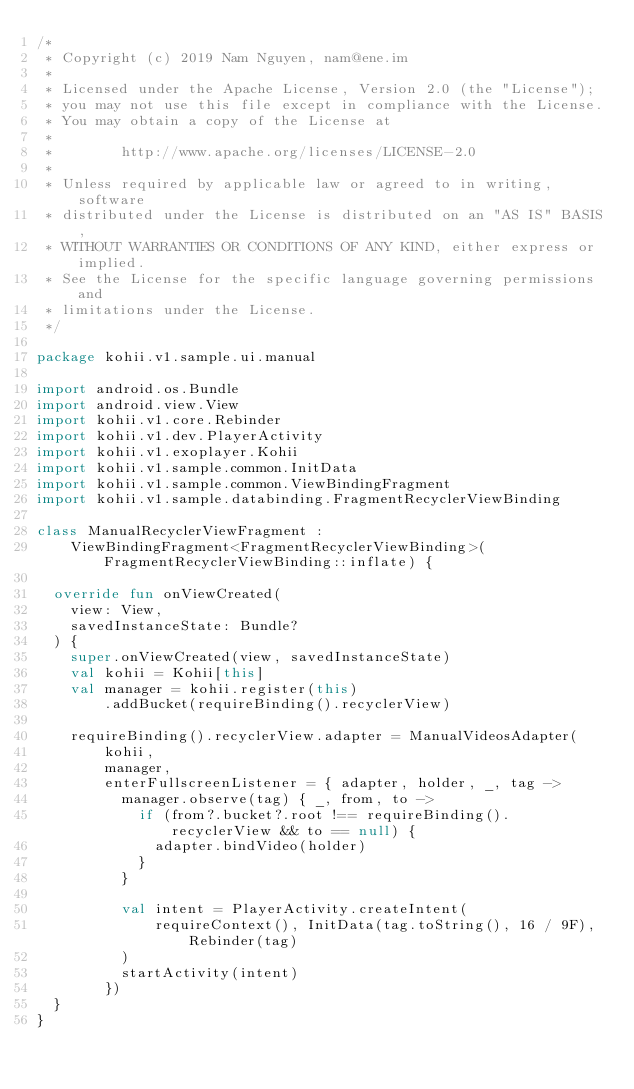<code> <loc_0><loc_0><loc_500><loc_500><_Kotlin_>/*
 * Copyright (c) 2019 Nam Nguyen, nam@ene.im
 *
 * Licensed under the Apache License, Version 2.0 (the "License");
 * you may not use this file except in compliance with the License.
 * You may obtain a copy of the License at
 *
 *        http://www.apache.org/licenses/LICENSE-2.0
 *
 * Unless required by applicable law or agreed to in writing, software
 * distributed under the License is distributed on an "AS IS" BASIS,
 * WITHOUT WARRANTIES OR CONDITIONS OF ANY KIND, either express or implied.
 * See the License for the specific language governing permissions and
 * limitations under the License.
 */

package kohii.v1.sample.ui.manual

import android.os.Bundle
import android.view.View
import kohii.v1.core.Rebinder
import kohii.v1.dev.PlayerActivity
import kohii.v1.exoplayer.Kohii
import kohii.v1.sample.common.InitData
import kohii.v1.sample.common.ViewBindingFragment
import kohii.v1.sample.databinding.FragmentRecyclerViewBinding

class ManualRecyclerViewFragment :
    ViewBindingFragment<FragmentRecyclerViewBinding>(FragmentRecyclerViewBinding::inflate) {

  override fun onViewCreated(
    view: View,
    savedInstanceState: Bundle?
  ) {
    super.onViewCreated(view, savedInstanceState)
    val kohii = Kohii[this]
    val manager = kohii.register(this)
        .addBucket(requireBinding().recyclerView)

    requireBinding().recyclerView.adapter = ManualVideosAdapter(
        kohii,
        manager,
        enterFullscreenListener = { adapter, holder, _, tag ->
          manager.observe(tag) { _, from, to ->
            if (from?.bucket?.root !== requireBinding().recyclerView && to == null) {
              adapter.bindVideo(holder)
            }
          }

          val intent = PlayerActivity.createIntent(
              requireContext(), InitData(tag.toString(), 16 / 9F), Rebinder(tag)
          )
          startActivity(intent)
        })
  }
}
</code> 